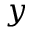<formula> <loc_0><loc_0><loc_500><loc_500>y</formula> 